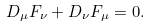Convert formula to latex. <formula><loc_0><loc_0><loc_500><loc_500>D _ { \mu } F _ { \nu } + D _ { \nu } F _ { \mu } = 0 .</formula> 